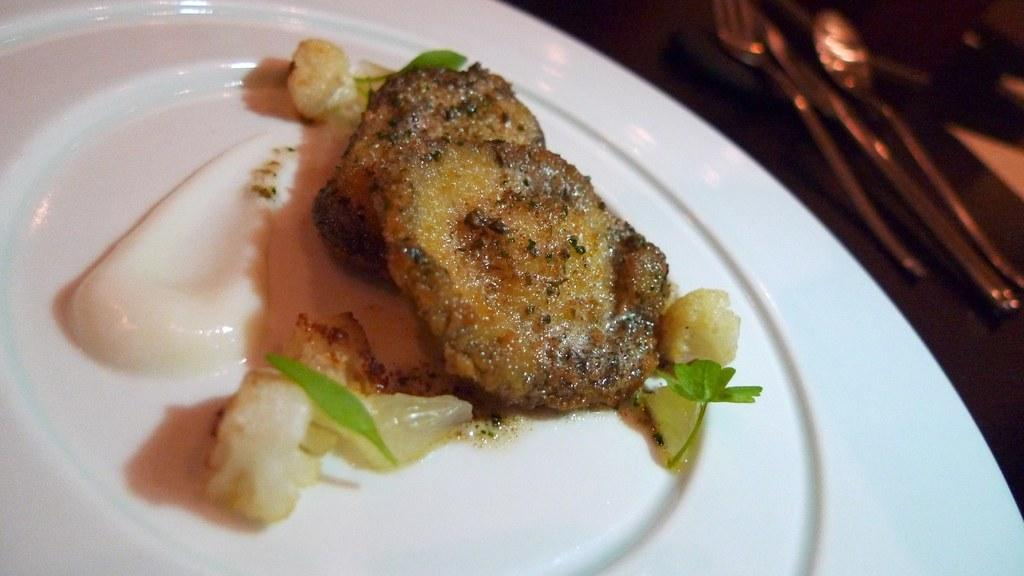What utensils are present on the wooden platform in the image? There is a spoon, knife, and fork on a wooden platform in the image. What can be found on the plate in the image? There is food on a plate in the image. What type of wave can be seen crashing on the shore in the image? There is no wave or shore present in the image; it features a wooden platform with utensils and a plate with food. 